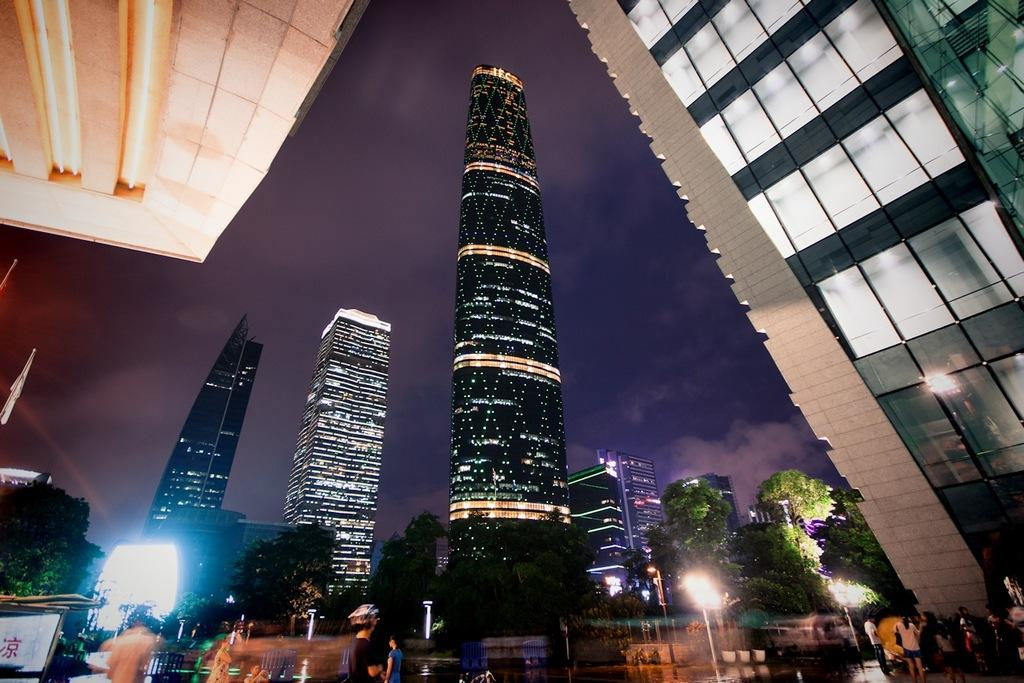How many people are in the image? There is a group of people standing in the image. What objects can be seen in the image besides the people? There are poles, lights, flags, trees, and buildings in the image. What is visible in the background of the image? The sky is visible in the image. How many books are stacked on the cent in the image? There are no books or cents present in the image. 